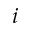<formula> <loc_0><loc_0><loc_500><loc_500>i</formula> 